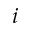<formula> <loc_0><loc_0><loc_500><loc_500>i</formula> 